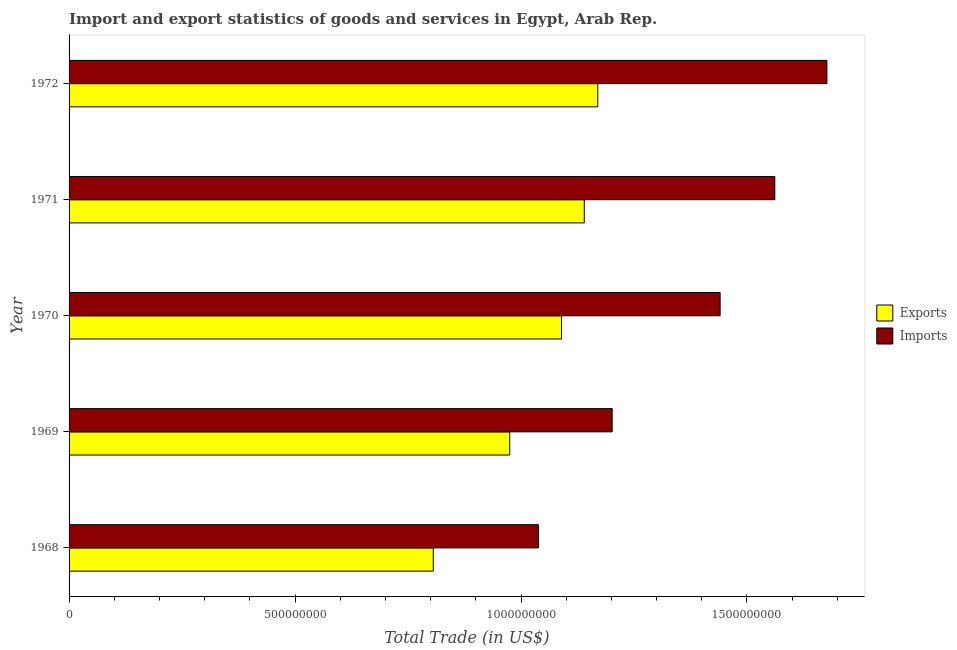How many different coloured bars are there?
Provide a succinct answer. 2. Are the number of bars per tick equal to the number of legend labels?
Your answer should be very brief. Yes. Are the number of bars on each tick of the Y-axis equal?
Offer a terse response. Yes. How many bars are there on the 1st tick from the bottom?
Ensure brevity in your answer.  2. What is the label of the 4th group of bars from the top?
Offer a very short reply. 1969. In how many cases, is the number of bars for a given year not equal to the number of legend labels?
Your response must be concise. 0. What is the imports of goods and services in 1968?
Offer a very short reply. 1.04e+09. Across all years, what is the maximum export of goods and services?
Provide a short and direct response. 1.17e+09. Across all years, what is the minimum export of goods and services?
Provide a short and direct response. 8.06e+08. In which year was the export of goods and services minimum?
Your answer should be compact. 1968. What is the total imports of goods and services in the graph?
Your answer should be very brief. 6.92e+09. What is the difference between the imports of goods and services in 1969 and that in 1972?
Keep it short and to the point. -4.75e+08. What is the difference between the export of goods and services in 1968 and the imports of goods and services in 1971?
Give a very brief answer. -7.56e+08. What is the average export of goods and services per year?
Your answer should be compact. 1.04e+09. In the year 1969, what is the difference between the imports of goods and services and export of goods and services?
Offer a terse response. 2.27e+08. In how many years, is the imports of goods and services greater than 1100000000 US$?
Offer a terse response. 4. What is the ratio of the export of goods and services in 1970 to that in 1971?
Offer a very short reply. 0.96. Is the difference between the export of goods and services in 1968 and 1971 greater than the difference between the imports of goods and services in 1968 and 1971?
Offer a very short reply. Yes. What is the difference between the highest and the second highest export of goods and services?
Your answer should be compact. 2.98e+07. What is the difference between the highest and the lowest export of goods and services?
Ensure brevity in your answer.  3.64e+08. What does the 1st bar from the top in 1971 represents?
Your answer should be very brief. Imports. What does the 2nd bar from the bottom in 1971 represents?
Offer a very short reply. Imports. Are all the bars in the graph horizontal?
Offer a very short reply. Yes. How many years are there in the graph?
Offer a terse response. 5. Where does the legend appear in the graph?
Your answer should be compact. Center right. How are the legend labels stacked?
Offer a very short reply. Vertical. What is the title of the graph?
Make the answer very short. Import and export statistics of goods and services in Egypt, Arab Rep. Does "Primary income" appear as one of the legend labels in the graph?
Make the answer very short. No. What is the label or title of the X-axis?
Your answer should be very brief. Total Trade (in US$). What is the Total Trade (in US$) in Exports in 1968?
Your response must be concise. 8.06e+08. What is the Total Trade (in US$) of Imports in 1968?
Keep it short and to the point. 1.04e+09. What is the Total Trade (in US$) of Exports in 1969?
Offer a very short reply. 9.75e+08. What is the Total Trade (in US$) in Imports in 1969?
Offer a very short reply. 1.20e+09. What is the Total Trade (in US$) of Exports in 1970?
Offer a very short reply. 1.09e+09. What is the Total Trade (in US$) of Imports in 1970?
Your answer should be compact. 1.44e+09. What is the Total Trade (in US$) in Exports in 1971?
Provide a short and direct response. 1.14e+09. What is the Total Trade (in US$) of Imports in 1971?
Offer a very short reply. 1.56e+09. What is the Total Trade (in US$) of Exports in 1972?
Give a very brief answer. 1.17e+09. What is the Total Trade (in US$) in Imports in 1972?
Your answer should be very brief. 1.68e+09. Across all years, what is the maximum Total Trade (in US$) in Exports?
Provide a short and direct response. 1.17e+09. Across all years, what is the maximum Total Trade (in US$) of Imports?
Provide a short and direct response. 1.68e+09. Across all years, what is the minimum Total Trade (in US$) of Exports?
Provide a succinct answer. 8.06e+08. Across all years, what is the minimum Total Trade (in US$) of Imports?
Offer a very short reply. 1.04e+09. What is the total Total Trade (in US$) of Exports in the graph?
Your response must be concise. 5.18e+09. What is the total Total Trade (in US$) of Imports in the graph?
Keep it short and to the point. 6.92e+09. What is the difference between the Total Trade (in US$) in Exports in 1968 and that in 1969?
Provide a succinct answer. -1.69e+08. What is the difference between the Total Trade (in US$) of Imports in 1968 and that in 1969?
Provide a succinct answer. -1.63e+08. What is the difference between the Total Trade (in US$) in Exports in 1968 and that in 1970?
Offer a very short reply. -2.84e+08. What is the difference between the Total Trade (in US$) of Imports in 1968 and that in 1970?
Provide a succinct answer. -4.02e+08. What is the difference between the Total Trade (in US$) of Exports in 1968 and that in 1971?
Your answer should be very brief. -3.34e+08. What is the difference between the Total Trade (in US$) in Imports in 1968 and that in 1971?
Give a very brief answer. -5.23e+08. What is the difference between the Total Trade (in US$) of Exports in 1968 and that in 1972?
Provide a short and direct response. -3.64e+08. What is the difference between the Total Trade (in US$) of Imports in 1968 and that in 1972?
Provide a succinct answer. -6.38e+08. What is the difference between the Total Trade (in US$) of Exports in 1969 and that in 1970?
Offer a very short reply. -1.15e+08. What is the difference between the Total Trade (in US$) in Imports in 1969 and that in 1970?
Give a very brief answer. -2.39e+08. What is the difference between the Total Trade (in US$) in Exports in 1969 and that in 1971?
Keep it short and to the point. -1.65e+08. What is the difference between the Total Trade (in US$) of Imports in 1969 and that in 1971?
Your answer should be very brief. -3.60e+08. What is the difference between the Total Trade (in US$) of Exports in 1969 and that in 1972?
Your answer should be compact. -1.95e+08. What is the difference between the Total Trade (in US$) in Imports in 1969 and that in 1972?
Offer a terse response. -4.75e+08. What is the difference between the Total Trade (in US$) of Exports in 1970 and that in 1971?
Provide a succinct answer. -5.03e+07. What is the difference between the Total Trade (in US$) of Imports in 1970 and that in 1971?
Your response must be concise. -1.21e+08. What is the difference between the Total Trade (in US$) in Exports in 1970 and that in 1972?
Offer a terse response. -8.02e+07. What is the difference between the Total Trade (in US$) in Imports in 1970 and that in 1972?
Keep it short and to the point. -2.36e+08. What is the difference between the Total Trade (in US$) in Exports in 1971 and that in 1972?
Your response must be concise. -2.98e+07. What is the difference between the Total Trade (in US$) in Imports in 1971 and that in 1972?
Make the answer very short. -1.15e+08. What is the difference between the Total Trade (in US$) in Exports in 1968 and the Total Trade (in US$) in Imports in 1969?
Give a very brief answer. -3.96e+08. What is the difference between the Total Trade (in US$) in Exports in 1968 and the Total Trade (in US$) in Imports in 1970?
Ensure brevity in your answer.  -6.35e+08. What is the difference between the Total Trade (in US$) of Exports in 1968 and the Total Trade (in US$) of Imports in 1971?
Make the answer very short. -7.56e+08. What is the difference between the Total Trade (in US$) in Exports in 1968 and the Total Trade (in US$) in Imports in 1972?
Offer a terse response. -8.71e+08. What is the difference between the Total Trade (in US$) of Exports in 1969 and the Total Trade (in US$) of Imports in 1970?
Your answer should be very brief. -4.66e+08. What is the difference between the Total Trade (in US$) of Exports in 1969 and the Total Trade (in US$) of Imports in 1971?
Make the answer very short. -5.87e+08. What is the difference between the Total Trade (in US$) in Exports in 1969 and the Total Trade (in US$) in Imports in 1972?
Provide a short and direct response. -7.02e+08. What is the difference between the Total Trade (in US$) in Exports in 1970 and the Total Trade (in US$) in Imports in 1971?
Your response must be concise. -4.72e+08. What is the difference between the Total Trade (in US$) in Exports in 1970 and the Total Trade (in US$) in Imports in 1972?
Your answer should be very brief. -5.87e+08. What is the difference between the Total Trade (in US$) in Exports in 1971 and the Total Trade (in US$) in Imports in 1972?
Provide a short and direct response. -5.37e+08. What is the average Total Trade (in US$) in Exports per year?
Your answer should be very brief. 1.04e+09. What is the average Total Trade (in US$) of Imports per year?
Keep it short and to the point. 1.38e+09. In the year 1968, what is the difference between the Total Trade (in US$) in Exports and Total Trade (in US$) in Imports?
Your answer should be very brief. -2.33e+08. In the year 1969, what is the difference between the Total Trade (in US$) in Exports and Total Trade (in US$) in Imports?
Your answer should be compact. -2.27e+08. In the year 1970, what is the difference between the Total Trade (in US$) of Exports and Total Trade (in US$) of Imports?
Provide a short and direct response. -3.51e+08. In the year 1971, what is the difference between the Total Trade (in US$) in Exports and Total Trade (in US$) in Imports?
Offer a terse response. -4.22e+08. In the year 1972, what is the difference between the Total Trade (in US$) in Exports and Total Trade (in US$) in Imports?
Ensure brevity in your answer.  -5.07e+08. What is the ratio of the Total Trade (in US$) in Exports in 1968 to that in 1969?
Make the answer very short. 0.83. What is the ratio of the Total Trade (in US$) of Imports in 1968 to that in 1969?
Your response must be concise. 0.86. What is the ratio of the Total Trade (in US$) of Exports in 1968 to that in 1970?
Your answer should be compact. 0.74. What is the ratio of the Total Trade (in US$) of Imports in 1968 to that in 1970?
Offer a terse response. 0.72. What is the ratio of the Total Trade (in US$) of Exports in 1968 to that in 1971?
Make the answer very short. 0.71. What is the ratio of the Total Trade (in US$) of Imports in 1968 to that in 1971?
Give a very brief answer. 0.67. What is the ratio of the Total Trade (in US$) of Exports in 1968 to that in 1972?
Ensure brevity in your answer.  0.69. What is the ratio of the Total Trade (in US$) of Imports in 1968 to that in 1972?
Your answer should be compact. 0.62. What is the ratio of the Total Trade (in US$) in Exports in 1969 to that in 1970?
Provide a short and direct response. 0.89. What is the ratio of the Total Trade (in US$) in Imports in 1969 to that in 1970?
Give a very brief answer. 0.83. What is the ratio of the Total Trade (in US$) of Exports in 1969 to that in 1971?
Your answer should be compact. 0.86. What is the ratio of the Total Trade (in US$) of Imports in 1969 to that in 1971?
Offer a very short reply. 0.77. What is the ratio of the Total Trade (in US$) of Exports in 1969 to that in 1972?
Give a very brief answer. 0.83. What is the ratio of the Total Trade (in US$) of Imports in 1969 to that in 1972?
Offer a very short reply. 0.72. What is the ratio of the Total Trade (in US$) in Exports in 1970 to that in 1971?
Give a very brief answer. 0.96. What is the ratio of the Total Trade (in US$) in Imports in 1970 to that in 1971?
Provide a succinct answer. 0.92. What is the ratio of the Total Trade (in US$) in Exports in 1970 to that in 1972?
Provide a succinct answer. 0.93. What is the ratio of the Total Trade (in US$) in Imports in 1970 to that in 1972?
Offer a terse response. 0.86. What is the ratio of the Total Trade (in US$) in Exports in 1971 to that in 1972?
Make the answer very short. 0.97. What is the ratio of the Total Trade (in US$) of Imports in 1971 to that in 1972?
Offer a terse response. 0.93. What is the difference between the highest and the second highest Total Trade (in US$) in Exports?
Keep it short and to the point. 2.98e+07. What is the difference between the highest and the second highest Total Trade (in US$) in Imports?
Keep it short and to the point. 1.15e+08. What is the difference between the highest and the lowest Total Trade (in US$) in Exports?
Your answer should be compact. 3.64e+08. What is the difference between the highest and the lowest Total Trade (in US$) in Imports?
Your response must be concise. 6.38e+08. 